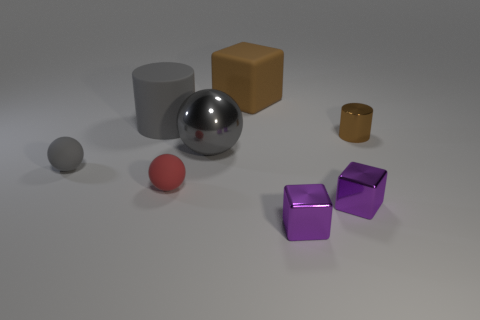What is the size of the rubber cylinder?
Your answer should be compact. Large. There is a large sphere that is made of the same material as the tiny cylinder; what is its color?
Your answer should be compact. Gray. What number of purple objects have the same material as the big gray cylinder?
Keep it short and to the point. 0. There is a large metal sphere; does it have the same color as the big rubber object that is right of the large ball?
Your answer should be compact. No. There is a block behind the large matte object on the left side of the large brown object; what is its color?
Your answer should be very brief. Brown. What color is the matte block that is the same size as the gray metal sphere?
Provide a succinct answer. Brown. Are there any other large gray objects of the same shape as the gray shiny thing?
Offer a terse response. No. There is a red thing; what shape is it?
Make the answer very short. Sphere. Are there more big objects behind the gray shiny object than small gray rubber spheres on the left side of the gray matte ball?
Give a very brief answer. Yes. How many other things are the same size as the matte cylinder?
Your answer should be compact. 2. 